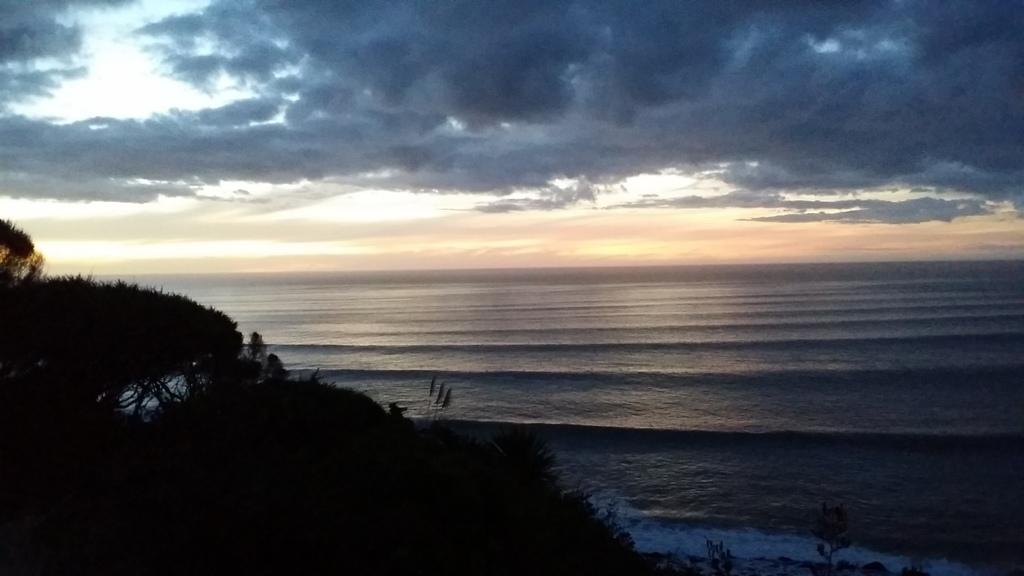What type of vegetation can be seen in the image? There are trees in the image. What natural element is visible in the image besides the trees? There is water visible in the image. What can be seen in the background of the image? The sky is visible in the background of the image. How many shops can be seen in the image? There are no shops present in the image. Is there a horse visible in the image? There is no horse present in the image. 